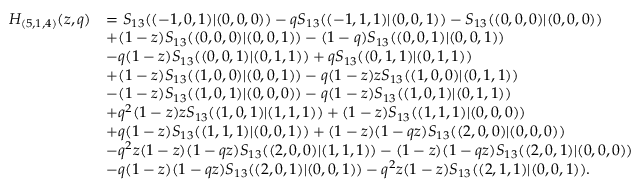<formula> <loc_0><loc_0><loc_500><loc_500>\begin{array} { r l } { H _ { ( 5 , 1 , 4 ) } ( z , q ) } & { = S _ { 1 3 } ( ( - 1 , 0 , 1 ) | ( 0 , 0 , 0 ) ) - q S _ { 1 3 } ( ( - 1 , 1 , 1 ) | ( 0 , 0 , 1 ) ) - S _ { 1 3 } ( ( 0 , 0 , 0 ) | ( 0 , 0 , 0 ) ) } \\ & { + ( 1 - z ) S _ { 1 3 } ( ( 0 , 0 , 0 ) | ( 0 , 0 , 1 ) ) - ( 1 - q ) S _ { 1 3 } ( ( 0 , 0 , 1 ) | ( 0 , 0 , 1 ) ) } \\ & { - q ( 1 - z ) S _ { 1 3 } ( ( 0 , 0 , 1 ) | ( 0 , 1 , 1 ) ) + q S _ { 1 3 } ( ( 0 , 1 , 1 ) | ( 0 , 1 , 1 ) ) } \\ & { + ( 1 - z ) S _ { 1 3 } ( ( 1 , 0 , 0 ) | ( 0 , 0 , 1 ) ) - q ( 1 - z ) z S _ { 1 3 } ( ( 1 , 0 , 0 ) | ( 0 , 1 , 1 ) ) } \\ & { - ( 1 - z ) S _ { 1 3 } ( ( 1 , 0 , 1 ) | ( 0 , 0 , 0 ) ) - q ( 1 - z ) S _ { 1 3 } ( ( 1 , 0 , 1 ) | ( 0 , 1 , 1 ) ) } \\ & { + q ^ { 2 } ( 1 - z ) z S _ { 1 3 } ( ( 1 , 0 , 1 ) | ( 1 , 1 , 1 ) ) + ( 1 - z ) S _ { 1 3 } ( ( 1 , 1 , 1 ) | ( 0 , 0 , 0 ) ) } \\ & { + q ( 1 - z ) S _ { 1 3 } ( ( 1 , 1 , 1 ) | ( 0 , 0 , 1 ) ) + ( 1 - z ) ( 1 - q z ) S _ { 1 3 } ( ( 2 , 0 , 0 ) | ( 0 , 0 , 0 ) ) } \\ & { - q ^ { 2 } z ( 1 - z ) ( 1 - q z ) S _ { 1 3 } ( ( 2 , 0 , 0 ) | ( 1 , 1 , 1 ) ) - ( 1 - z ) ( 1 - q z ) S _ { 1 3 } ( ( 2 , 0 , 1 ) | ( 0 , 0 , 0 ) ) } \\ & { - q ( 1 - z ) ( 1 - q z ) S _ { 1 3 } ( ( 2 , 0 , 1 ) | ( 0 , 0 , 1 ) ) - q ^ { 2 } z ( 1 - z ) S _ { 1 3 } ( ( 2 , 1 , 1 ) | ( 0 , 0 , 1 ) ) . } \end{array}</formula> 